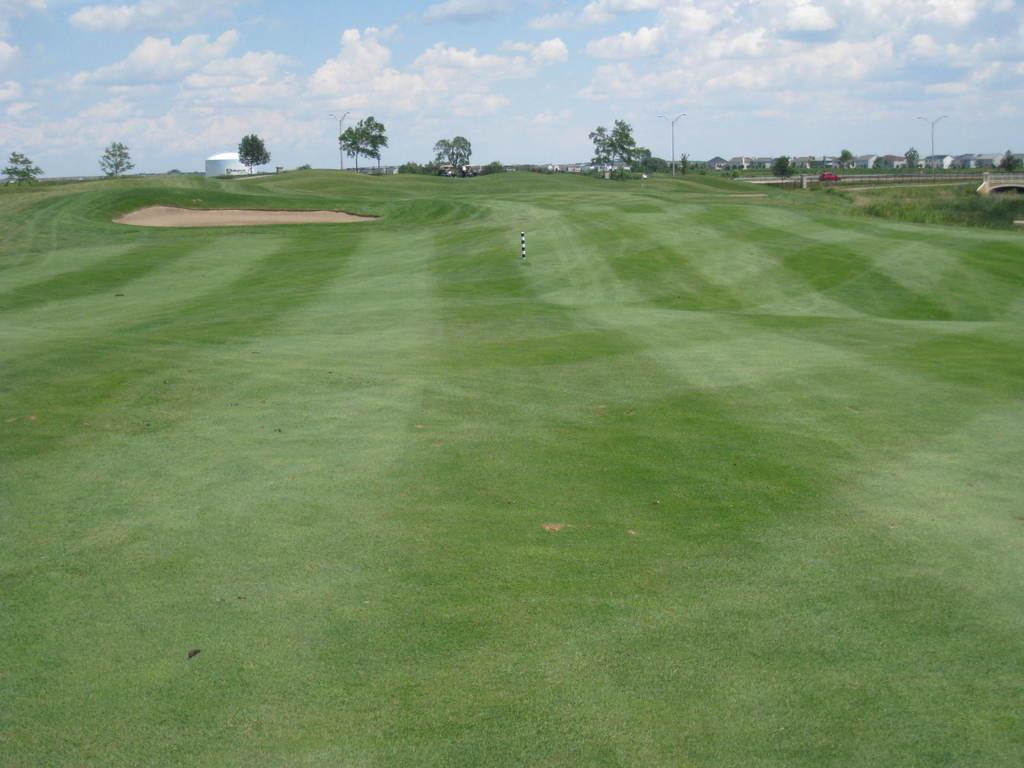Describe this image in one or two sentences. In this image in the front there's grass on the ground. In the background there are trees and buildings and the sky is cloudy 